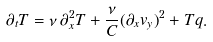<formula> <loc_0><loc_0><loc_500><loc_500>\partial _ { t } T = \nu \, \partial _ { x } ^ { 2 } T + \frac { \nu } { C } { ( \partial _ { x } v _ { y } ) } ^ { 2 } + T q .</formula> 